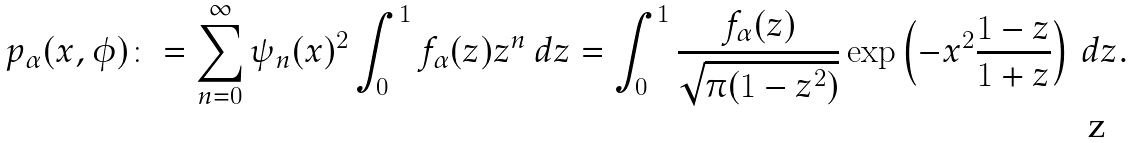Convert formula to latex. <formula><loc_0><loc_0><loc_500><loc_500>p _ { \alpha } ( x , \phi ) \colon = \sum _ { n = 0 } ^ { \infty } \psi _ { n } ( x ) ^ { 2 } \int _ { 0 } ^ { 1 } f _ { \alpha } ( z ) z ^ { n } \, d z = \int _ { 0 } ^ { 1 } \frac { f _ { \alpha } ( z ) } { \sqrt { \pi ( 1 - z ^ { 2 } ) } } \exp \left ( - x ^ { 2 } \frac { 1 - z } { 1 + z } \right ) \, d z .</formula> 